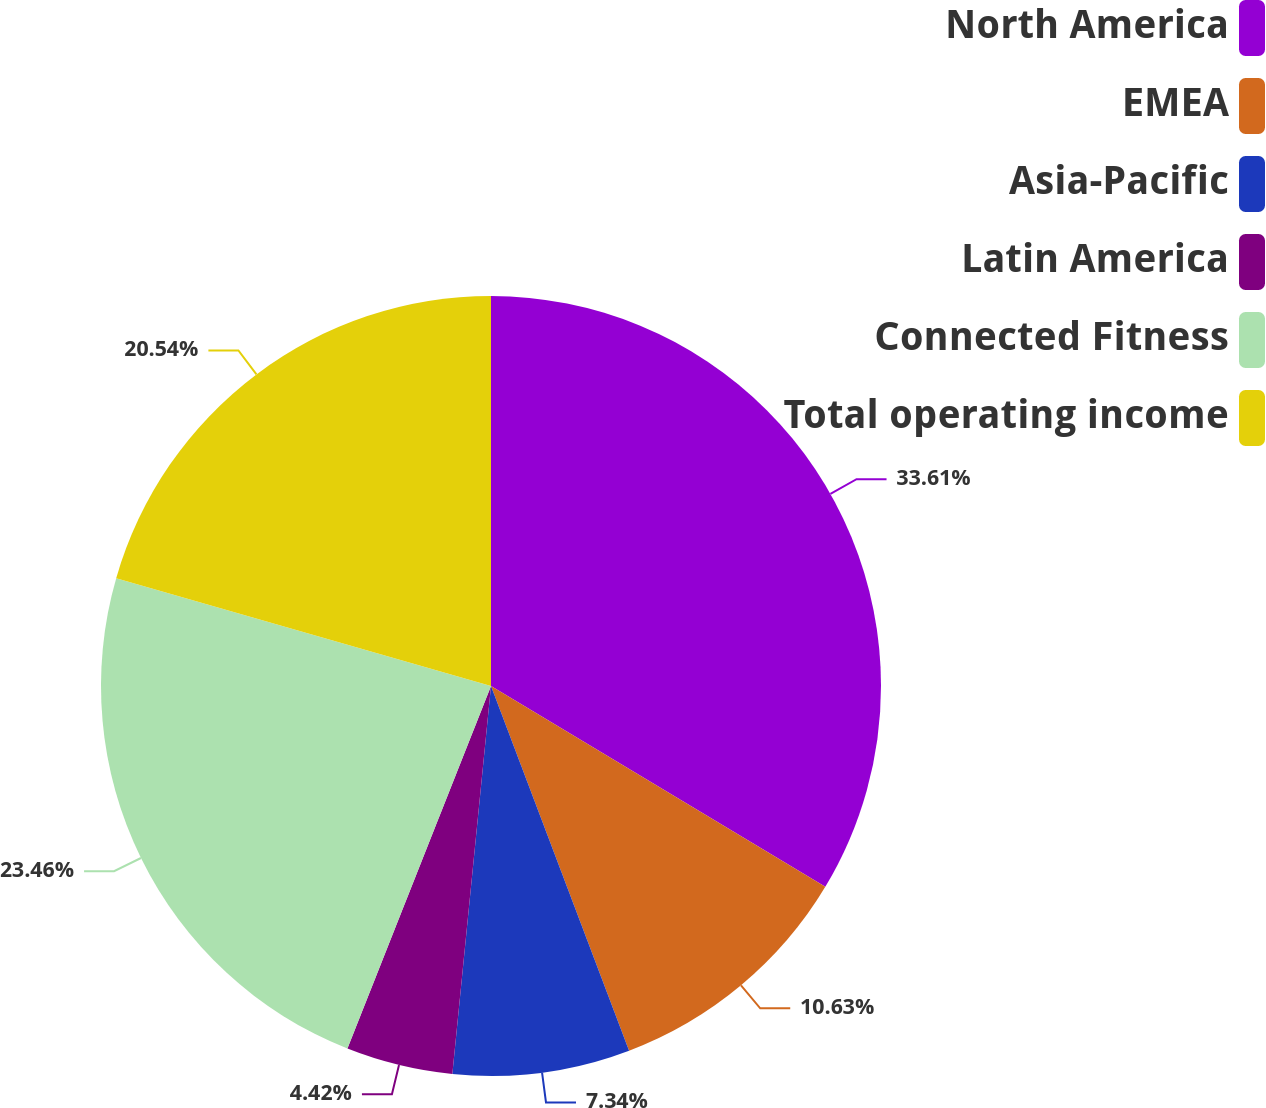<chart> <loc_0><loc_0><loc_500><loc_500><pie_chart><fcel>North America<fcel>EMEA<fcel>Asia-Pacific<fcel>Latin America<fcel>Connected Fitness<fcel>Total operating income<nl><fcel>33.61%<fcel>10.63%<fcel>7.34%<fcel>4.42%<fcel>23.46%<fcel>20.54%<nl></chart> 